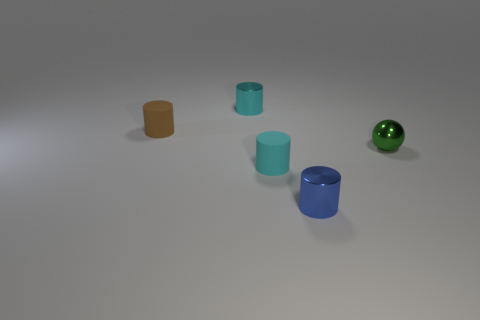Which of the cylinders would hold the least amount of water? The cylinder with the orange-brown hue on the left would hold the least amount of water since it appears to be the shortest and has the smallest diameter. 